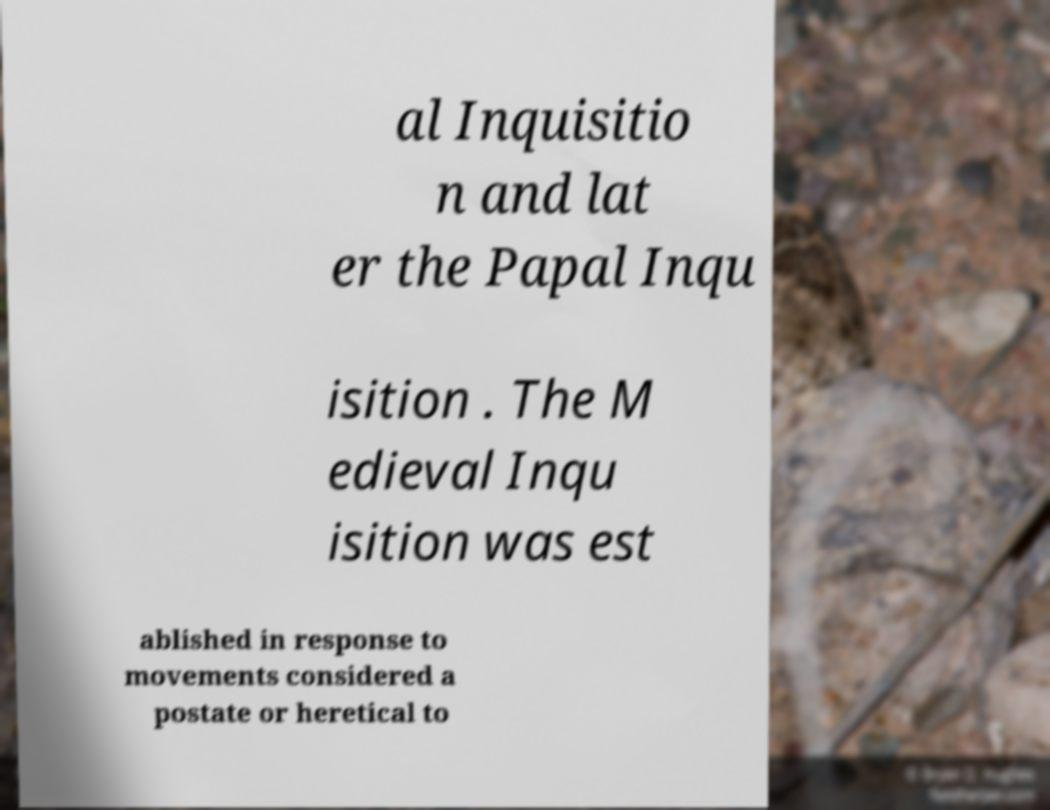There's text embedded in this image that I need extracted. Can you transcribe it verbatim? al Inquisitio n and lat er the Papal Inqu isition . The M edieval Inqu isition was est ablished in response to movements considered a postate or heretical to 